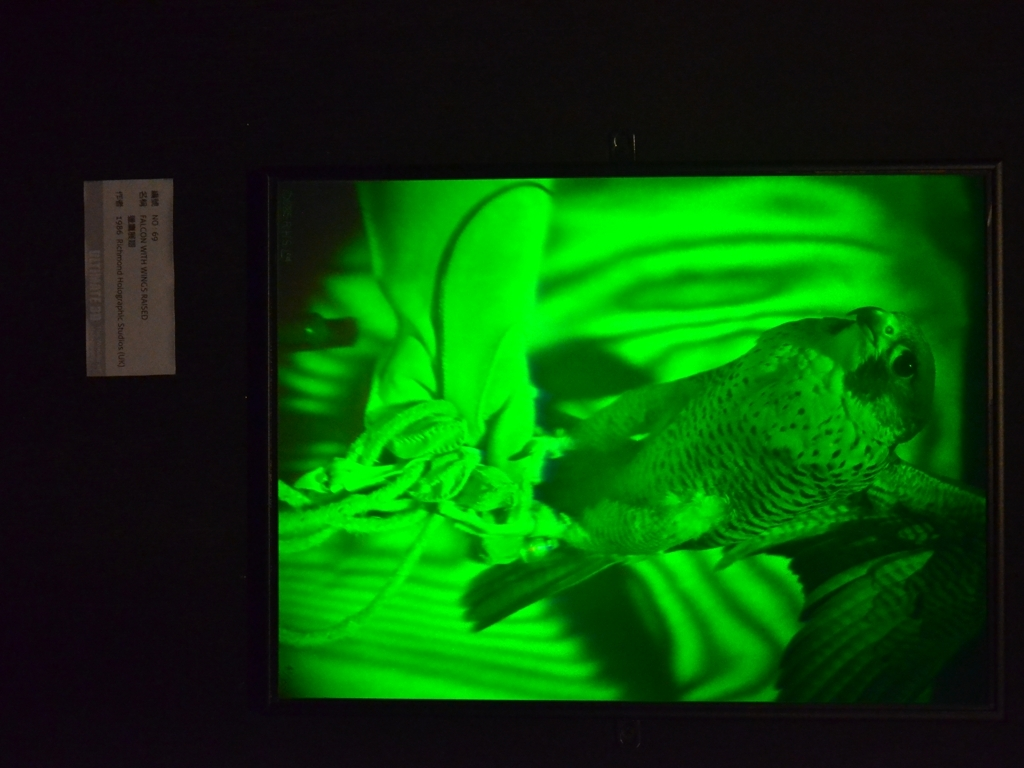How does the angle of the shot influence the viewer's perception of the image? The angle of the shot in this image appears to be slightly below the bird, looking up at it, which can give the viewer a sense of awe or admiration. It makes the bird seem larger and more imposing, potentially elevating its status as the focal point and presenting it in a powerful or majestic light. 